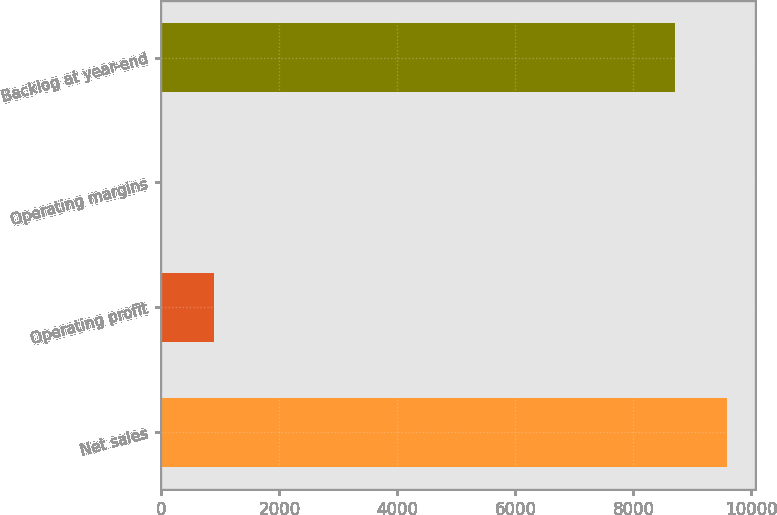Convert chart to OTSL. <chart><loc_0><loc_0><loc_500><loc_500><bar_chart><fcel>Net sales<fcel>Operating profit<fcel>Operating margins<fcel>Backlog at year-end<nl><fcel>9583.69<fcel>892.79<fcel>9.1<fcel>8700<nl></chart> 